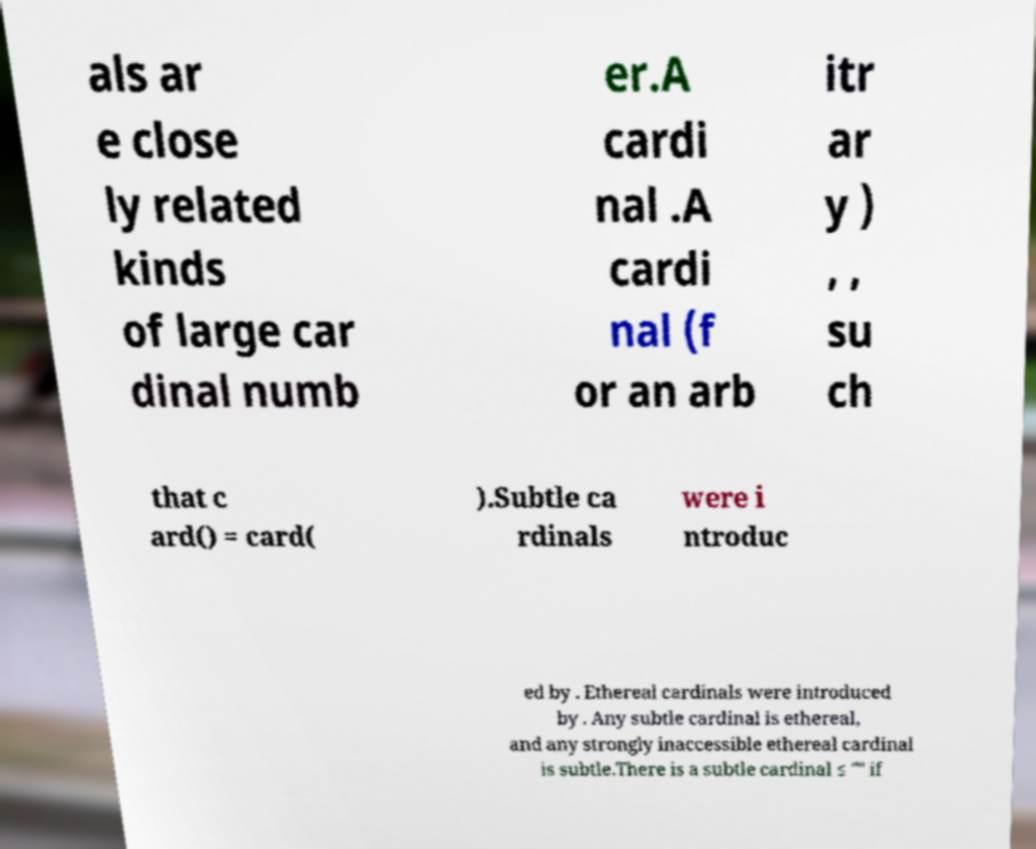Could you assist in decoding the text presented in this image and type it out clearly? als ar e close ly related kinds of large car dinal numb er.A cardi nal .A cardi nal (f or an arb itr ar y ) , , su ch that c ard() = card( ).Subtle ca rdinals were i ntroduc ed by . Ethereal cardinals were introduced by . Any subtle cardinal is ethereal, and any strongly inaccessible ethereal cardinal is subtle.There is a subtle cardinal ≤ "" if 